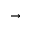<formula> <loc_0><loc_0><loc_500><loc_500>\rightarrow</formula> 